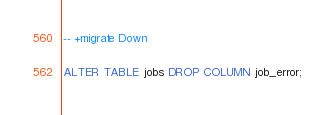Convert code to text. <code><loc_0><loc_0><loc_500><loc_500><_SQL_>
-- +migrate Down

ALTER TABLE jobs DROP COLUMN job_error;
</code> 